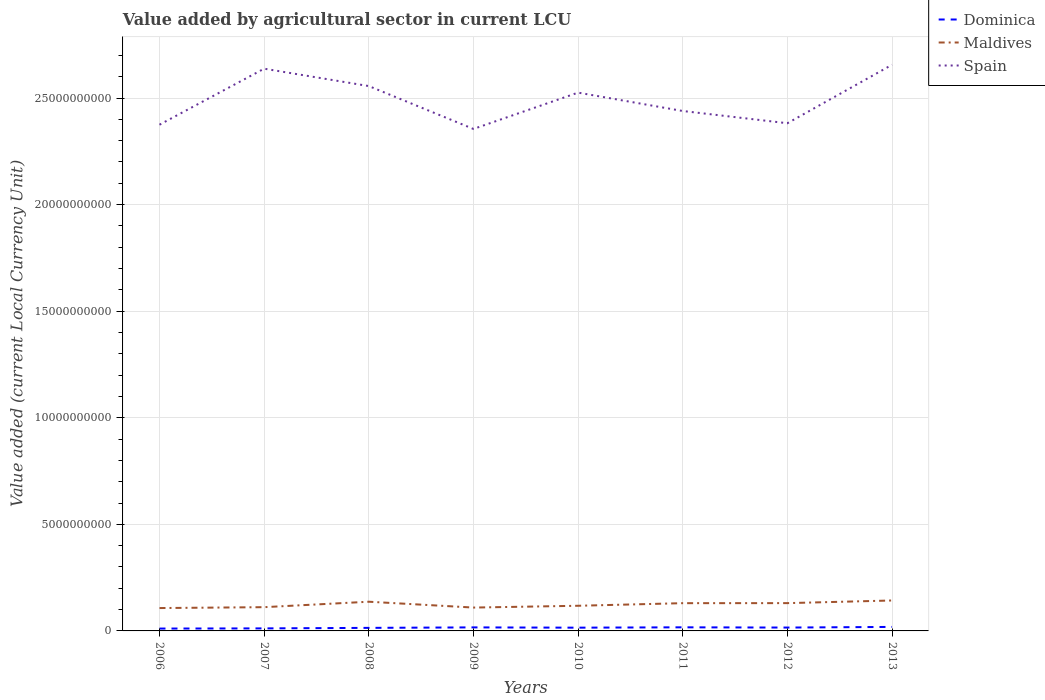Does the line corresponding to Spain intersect with the line corresponding to Maldives?
Your answer should be very brief. No. Is the number of lines equal to the number of legend labels?
Provide a succinct answer. Yes. Across all years, what is the maximum value added by agricultural sector in Dominica?
Make the answer very short. 1.11e+08. In which year was the value added by agricultural sector in Maldives maximum?
Offer a very short reply. 2006. What is the total value added by agricultural sector in Dominica in the graph?
Give a very brief answer. -4.83e+06. What is the difference between the highest and the second highest value added by agricultural sector in Maldives?
Your response must be concise. 3.55e+08. Is the value added by agricultural sector in Maldives strictly greater than the value added by agricultural sector in Spain over the years?
Give a very brief answer. Yes. What is the difference between two consecutive major ticks on the Y-axis?
Offer a very short reply. 5.00e+09. Does the graph contain any zero values?
Give a very brief answer. No. Does the graph contain grids?
Provide a short and direct response. Yes. How are the legend labels stacked?
Offer a very short reply. Vertical. What is the title of the graph?
Ensure brevity in your answer.  Value added by agricultural sector in current LCU. What is the label or title of the X-axis?
Provide a succinct answer. Years. What is the label or title of the Y-axis?
Offer a very short reply. Value added (current Local Currency Unit). What is the Value added (current Local Currency Unit) in Dominica in 2006?
Your answer should be compact. 1.11e+08. What is the Value added (current Local Currency Unit) in Maldives in 2006?
Provide a short and direct response. 1.07e+09. What is the Value added (current Local Currency Unit) in Spain in 2006?
Make the answer very short. 2.37e+1. What is the Value added (current Local Currency Unit) in Dominica in 2007?
Ensure brevity in your answer.  1.19e+08. What is the Value added (current Local Currency Unit) in Maldives in 2007?
Provide a succinct answer. 1.11e+09. What is the Value added (current Local Currency Unit) in Spain in 2007?
Your answer should be compact. 2.64e+1. What is the Value added (current Local Currency Unit) in Dominica in 2008?
Offer a very short reply. 1.43e+08. What is the Value added (current Local Currency Unit) in Maldives in 2008?
Provide a short and direct response. 1.37e+09. What is the Value added (current Local Currency Unit) in Spain in 2008?
Make the answer very short. 2.56e+1. What is the Value added (current Local Currency Unit) of Dominica in 2009?
Your response must be concise. 1.66e+08. What is the Value added (current Local Currency Unit) in Maldives in 2009?
Provide a succinct answer. 1.10e+09. What is the Value added (current Local Currency Unit) in Spain in 2009?
Provide a short and direct response. 2.35e+1. What is the Value added (current Local Currency Unit) of Dominica in 2010?
Give a very brief answer. 1.53e+08. What is the Value added (current Local Currency Unit) in Maldives in 2010?
Offer a terse response. 1.18e+09. What is the Value added (current Local Currency Unit) of Spain in 2010?
Your answer should be very brief. 2.53e+1. What is the Value added (current Local Currency Unit) of Dominica in 2011?
Ensure brevity in your answer.  1.69e+08. What is the Value added (current Local Currency Unit) of Maldives in 2011?
Your response must be concise. 1.30e+09. What is the Value added (current Local Currency Unit) in Spain in 2011?
Give a very brief answer. 2.44e+1. What is the Value added (current Local Currency Unit) of Dominica in 2012?
Provide a succinct answer. 1.58e+08. What is the Value added (current Local Currency Unit) of Maldives in 2012?
Keep it short and to the point. 1.30e+09. What is the Value added (current Local Currency Unit) in Spain in 2012?
Give a very brief answer. 2.38e+1. What is the Value added (current Local Currency Unit) in Dominica in 2013?
Make the answer very short. 1.88e+08. What is the Value added (current Local Currency Unit) in Maldives in 2013?
Provide a succinct answer. 1.43e+09. What is the Value added (current Local Currency Unit) of Spain in 2013?
Provide a succinct answer. 2.66e+1. Across all years, what is the maximum Value added (current Local Currency Unit) of Dominica?
Your answer should be very brief. 1.88e+08. Across all years, what is the maximum Value added (current Local Currency Unit) of Maldives?
Provide a succinct answer. 1.43e+09. Across all years, what is the maximum Value added (current Local Currency Unit) in Spain?
Offer a terse response. 2.66e+1. Across all years, what is the minimum Value added (current Local Currency Unit) in Dominica?
Provide a short and direct response. 1.11e+08. Across all years, what is the minimum Value added (current Local Currency Unit) of Maldives?
Offer a very short reply. 1.07e+09. Across all years, what is the minimum Value added (current Local Currency Unit) in Spain?
Provide a succinct answer. 2.35e+1. What is the total Value added (current Local Currency Unit) in Dominica in the graph?
Provide a succinct answer. 1.21e+09. What is the total Value added (current Local Currency Unit) of Maldives in the graph?
Make the answer very short. 9.87e+09. What is the total Value added (current Local Currency Unit) of Spain in the graph?
Keep it short and to the point. 1.99e+11. What is the difference between the Value added (current Local Currency Unit) of Dominica in 2006 and that in 2007?
Your answer should be very brief. -8.21e+06. What is the difference between the Value added (current Local Currency Unit) of Maldives in 2006 and that in 2007?
Provide a short and direct response. -4.16e+07. What is the difference between the Value added (current Local Currency Unit) in Spain in 2006 and that in 2007?
Ensure brevity in your answer.  -2.63e+09. What is the difference between the Value added (current Local Currency Unit) of Dominica in 2006 and that in 2008?
Make the answer very short. -3.24e+07. What is the difference between the Value added (current Local Currency Unit) of Maldives in 2006 and that in 2008?
Your answer should be very brief. -2.97e+08. What is the difference between the Value added (current Local Currency Unit) in Spain in 2006 and that in 2008?
Provide a short and direct response. -1.81e+09. What is the difference between the Value added (current Local Currency Unit) of Dominica in 2006 and that in 2009?
Keep it short and to the point. -5.51e+07. What is the difference between the Value added (current Local Currency Unit) in Maldives in 2006 and that in 2009?
Ensure brevity in your answer.  -2.32e+07. What is the difference between the Value added (current Local Currency Unit) of Spain in 2006 and that in 2009?
Provide a succinct answer. 1.99e+08. What is the difference between the Value added (current Local Currency Unit) of Dominica in 2006 and that in 2010?
Your answer should be very brief. -4.22e+07. What is the difference between the Value added (current Local Currency Unit) in Maldives in 2006 and that in 2010?
Provide a short and direct response. -1.07e+08. What is the difference between the Value added (current Local Currency Unit) of Spain in 2006 and that in 2010?
Keep it short and to the point. -1.50e+09. What is the difference between the Value added (current Local Currency Unit) in Dominica in 2006 and that in 2011?
Provide a succinct answer. -5.85e+07. What is the difference between the Value added (current Local Currency Unit) in Maldives in 2006 and that in 2011?
Your answer should be very brief. -2.29e+08. What is the difference between the Value added (current Local Currency Unit) in Spain in 2006 and that in 2011?
Provide a short and direct response. -6.43e+08. What is the difference between the Value added (current Local Currency Unit) in Dominica in 2006 and that in 2012?
Offer a very short reply. -4.71e+07. What is the difference between the Value added (current Local Currency Unit) in Maldives in 2006 and that in 2012?
Your response must be concise. -2.31e+08. What is the difference between the Value added (current Local Currency Unit) of Spain in 2006 and that in 2012?
Offer a terse response. -6.90e+07. What is the difference between the Value added (current Local Currency Unit) in Dominica in 2006 and that in 2013?
Offer a terse response. -7.72e+07. What is the difference between the Value added (current Local Currency Unit) of Maldives in 2006 and that in 2013?
Ensure brevity in your answer.  -3.55e+08. What is the difference between the Value added (current Local Currency Unit) of Spain in 2006 and that in 2013?
Your answer should be very brief. -2.81e+09. What is the difference between the Value added (current Local Currency Unit) in Dominica in 2007 and that in 2008?
Offer a terse response. -2.42e+07. What is the difference between the Value added (current Local Currency Unit) of Maldives in 2007 and that in 2008?
Your response must be concise. -2.56e+08. What is the difference between the Value added (current Local Currency Unit) of Spain in 2007 and that in 2008?
Offer a very short reply. 8.15e+08. What is the difference between the Value added (current Local Currency Unit) of Dominica in 2007 and that in 2009?
Your response must be concise. -4.69e+07. What is the difference between the Value added (current Local Currency Unit) of Maldives in 2007 and that in 2009?
Provide a short and direct response. 1.84e+07. What is the difference between the Value added (current Local Currency Unit) in Spain in 2007 and that in 2009?
Provide a short and direct response. 2.83e+09. What is the difference between the Value added (current Local Currency Unit) in Dominica in 2007 and that in 2010?
Your response must be concise. -3.40e+07. What is the difference between the Value added (current Local Currency Unit) in Maldives in 2007 and that in 2010?
Your answer should be compact. -6.58e+07. What is the difference between the Value added (current Local Currency Unit) in Spain in 2007 and that in 2010?
Offer a terse response. 1.12e+09. What is the difference between the Value added (current Local Currency Unit) of Dominica in 2007 and that in 2011?
Your answer should be compact. -5.03e+07. What is the difference between the Value added (current Local Currency Unit) of Maldives in 2007 and that in 2011?
Offer a terse response. -1.88e+08. What is the difference between the Value added (current Local Currency Unit) of Spain in 2007 and that in 2011?
Your answer should be very brief. 1.98e+09. What is the difference between the Value added (current Local Currency Unit) in Dominica in 2007 and that in 2012?
Offer a very short reply. -3.89e+07. What is the difference between the Value added (current Local Currency Unit) of Maldives in 2007 and that in 2012?
Keep it short and to the point. -1.90e+08. What is the difference between the Value added (current Local Currency Unit) in Spain in 2007 and that in 2012?
Provide a succinct answer. 2.56e+09. What is the difference between the Value added (current Local Currency Unit) in Dominica in 2007 and that in 2013?
Your answer should be very brief. -6.90e+07. What is the difference between the Value added (current Local Currency Unit) of Maldives in 2007 and that in 2013?
Your answer should be compact. -3.14e+08. What is the difference between the Value added (current Local Currency Unit) in Spain in 2007 and that in 2013?
Your answer should be very brief. -1.84e+08. What is the difference between the Value added (current Local Currency Unit) in Dominica in 2008 and that in 2009?
Offer a very short reply. -2.27e+07. What is the difference between the Value added (current Local Currency Unit) in Maldives in 2008 and that in 2009?
Give a very brief answer. 2.74e+08. What is the difference between the Value added (current Local Currency Unit) in Spain in 2008 and that in 2009?
Your answer should be very brief. 2.01e+09. What is the difference between the Value added (current Local Currency Unit) of Dominica in 2008 and that in 2010?
Offer a very short reply. -9.81e+06. What is the difference between the Value added (current Local Currency Unit) of Maldives in 2008 and that in 2010?
Make the answer very short. 1.90e+08. What is the difference between the Value added (current Local Currency Unit) of Spain in 2008 and that in 2010?
Your answer should be very brief. 3.08e+08. What is the difference between the Value added (current Local Currency Unit) in Dominica in 2008 and that in 2011?
Give a very brief answer. -2.60e+07. What is the difference between the Value added (current Local Currency Unit) of Maldives in 2008 and that in 2011?
Your response must be concise. 6.81e+07. What is the difference between the Value added (current Local Currency Unit) in Spain in 2008 and that in 2011?
Give a very brief answer. 1.17e+09. What is the difference between the Value added (current Local Currency Unit) of Dominica in 2008 and that in 2012?
Give a very brief answer. -1.46e+07. What is the difference between the Value added (current Local Currency Unit) in Maldives in 2008 and that in 2012?
Your answer should be very brief. 6.62e+07. What is the difference between the Value added (current Local Currency Unit) of Spain in 2008 and that in 2012?
Ensure brevity in your answer.  1.74e+09. What is the difference between the Value added (current Local Currency Unit) in Dominica in 2008 and that in 2013?
Offer a terse response. -4.47e+07. What is the difference between the Value added (current Local Currency Unit) of Maldives in 2008 and that in 2013?
Give a very brief answer. -5.80e+07. What is the difference between the Value added (current Local Currency Unit) of Spain in 2008 and that in 2013?
Give a very brief answer. -9.99e+08. What is the difference between the Value added (current Local Currency Unit) of Dominica in 2009 and that in 2010?
Your answer should be very brief. 1.29e+07. What is the difference between the Value added (current Local Currency Unit) of Maldives in 2009 and that in 2010?
Your response must be concise. -8.42e+07. What is the difference between the Value added (current Local Currency Unit) of Spain in 2009 and that in 2010?
Provide a short and direct response. -1.70e+09. What is the difference between the Value added (current Local Currency Unit) of Dominica in 2009 and that in 2011?
Keep it short and to the point. -3.37e+06. What is the difference between the Value added (current Local Currency Unit) of Maldives in 2009 and that in 2011?
Ensure brevity in your answer.  -2.06e+08. What is the difference between the Value added (current Local Currency Unit) of Spain in 2009 and that in 2011?
Make the answer very short. -8.42e+08. What is the difference between the Value added (current Local Currency Unit) in Dominica in 2009 and that in 2012?
Keep it short and to the point. 8.03e+06. What is the difference between the Value added (current Local Currency Unit) in Maldives in 2009 and that in 2012?
Keep it short and to the point. -2.08e+08. What is the difference between the Value added (current Local Currency Unit) of Spain in 2009 and that in 2012?
Provide a short and direct response. -2.68e+08. What is the difference between the Value added (current Local Currency Unit) in Dominica in 2009 and that in 2013?
Provide a succinct answer. -2.21e+07. What is the difference between the Value added (current Local Currency Unit) of Maldives in 2009 and that in 2013?
Your answer should be very brief. -3.32e+08. What is the difference between the Value added (current Local Currency Unit) in Spain in 2009 and that in 2013?
Offer a terse response. -3.01e+09. What is the difference between the Value added (current Local Currency Unit) of Dominica in 2010 and that in 2011?
Offer a terse response. -1.62e+07. What is the difference between the Value added (current Local Currency Unit) of Maldives in 2010 and that in 2011?
Make the answer very short. -1.22e+08. What is the difference between the Value added (current Local Currency Unit) in Spain in 2010 and that in 2011?
Make the answer very short. 8.62e+08. What is the difference between the Value added (current Local Currency Unit) of Dominica in 2010 and that in 2012?
Your answer should be very brief. -4.83e+06. What is the difference between the Value added (current Local Currency Unit) in Maldives in 2010 and that in 2012?
Provide a succinct answer. -1.24e+08. What is the difference between the Value added (current Local Currency Unit) in Spain in 2010 and that in 2012?
Your answer should be very brief. 1.44e+09. What is the difference between the Value added (current Local Currency Unit) of Dominica in 2010 and that in 2013?
Offer a terse response. -3.49e+07. What is the difference between the Value added (current Local Currency Unit) in Maldives in 2010 and that in 2013?
Offer a terse response. -2.48e+08. What is the difference between the Value added (current Local Currency Unit) in Spain in 2010 and that in 2013?
Offer a very short reply. -1.31e+09. What is the difference between the Value added (current Local Currency Unit) of Dominica in 2011 and that in 2012?
Give a very brief answer. 1.14e+07. What is the difference between the Value added (current Local Currency Unit) in Maldives in 2011 and that in 2012?
Give a very brief answer. -1.90e+06. What is the difference between the Value added (current Local Currency Unit) of Spain in 2011 and that in 2012?
Your response must be concise. 5.74e+08. What is the difference between the Value added (current Local Currency Unit) of Dominica in 2011 and that in 2013?
Give a very brief answer. -1.87e+07. What is the difference between the Value added (current Local Currency Unit) of Maldives in 2011 and that in 2013?
Your response must be concise. -1.26e+08. What is the difference between the Value added (current Local Currency Unit) in Spain in 2011 and that in 2013?
Your answer should be very brief. -2.17e+09. What is the difference between the Value added (current Local Currency Unit) of Dominica in 2012 and that in 2013?
Make the answer very short. -3.01e+07. What is the difference between the Value added (current Local Currency Unit) of Maldives in 2012 and that in 2013?
Keep it short and to the point. -1.24e+08. What is the difference between the Value added (current Local Currency Unit) in Spain in 2012 and that in 2013?
Your response must be concise. -2.74e+09. What is the difference between the Value added (current Local Currency Unit) in Dominica in 2006 and the Value added (current Local Currency Unit) in Maldives in 2007?
Offer a terse response. -1.00e+09. What is the difference between the Value added (current Local Currency Unit) of Dominica in 2006 and the Value added (current Local Currency Unit) of Spain in 2007?
Your response must be concise. -2.63e+1. What is the difference between the Value added (current Local Currency Unit) of Maldives in 2006 and the Value added (current Local Currency Unit) of Spain in 2007?
Your response must be concise. -2.53e+1. What is the difference between the Value added (current Local Currency Unit) in Dominica in 2006 and the Value added (current Local Currency Unit) in Maldives in 2008?
Keep it short and to the point. -1.26e+09. What is the difference between the Value added (current Local Currency Unit) in Dominica in 2006 and the Value added (current Local Currency Unit) in Spain in 2008?
Keep it short and to the point. -2.55e+1. What is the difference between the Value added (current Local Currency Unit) in Maldives in 2006 and the Value added (current Local Currency Unit) in Spain in 2008?
Make the answer very short. -2.45e+1. What is the difference between the Value added (current Local Currency Unit) in Dominica in 2006 and the Value added (current Local Currency Unit) in Maldives in 2009?
Offer a very short reply. -9.85e+08. What is the difference between the Value added (current Local Currency Unit) in Dominica in 2006 and the Value added (current Local Currency Unit) in Spain in 2009?
Make the answer very short. -2.34e+1. What is the difference between the Value added (current Local Currency Unit) in Maldives in 2006 and the Value added (current Local Currency Unit) in Spain in 2009?
Your answer should be very brief. -2.25e+1. What is the difference between the Value added (current Local Currency Unit) in Dominica in 2006 and the Value added (current Local Currency Unit) in Maldives in 2010?
Offer a terse response. -1.07e+09. What is the difference between the Value added (current Local Currency Unit) in Dominica in 2006 and the Value added (current Local Currency Unit) in Spain in 2010?
Make the answer very short. -2.51e+1. What is the difference between the Value added (current Local Currency Unit) of Maldives in 2006 and the Value added (current Local Currency Unit) of Spain in 2010?
Offer a very short reply. -2.42e+1. What is the difference between the Value added (current Local Currency Unit) of Dominica in 2006 and the Value added (current Local Currency Unit) of Maldives in 2011?
Offer a very short reply. -1.19e+09. What is the difference between the Value added (current Local Currency Unit) of Dominica in 2006 and the Value added (current Local Currency Unit) of Spain in 2011?
Make the answer very short. -2.43e+1. What is the difference between the Value added (current Local Currency Unit) of Maldives in 2006 and the Value added (current Local Currency Unit) of Spain in 2011?
Offer a terse response. -2.33e+1. What is the difference between the Value added (current Local Currency Unit) of Dominica in 2006 and the Value added (current Local Currency Unit) of Maldives in 2012?
Give a very brief answer. -1.19e+09. What is the difference between the Value added (current Local Currency Unit) of Dominica in 2006 and the Value added (current Local Currency Unit) of Spain in 2012?
Offer a very short reply. -2.37e+1. What is the difference between the Value added (current Local Currency Unit) in Maldives in 2006 and the Value added (current Local Currency Unit) in Spain in 2012?
Provide a short and direct response. -2.27e+1. What is the difference between the Value added (current Local Currency Unit) of Dominica in 2006 and the Value added (current Local Currency Unit) of Maldives in 2013?
Provide a short and direct response. -1.32e+09. What is the difference between the Value added (current Local Currency Unit) in Dominica in 2006 and the Value added (current Local Currency Unit) in Spain in 2013?
Your answer should be compact. -2.64e+1. What is the difference between the Value added (current Local Currency Unit) of Maldives in 2006 and the Value added (current Local Currency Unit) of Spain in 2013?
Your response must be concise. -2.55e+1. What is the difference between the Value added (current Local Currency Unit) of Dominica in 2007 and the Value added (current Local Currency Unit) of Maldives in 2008?
Your answer should be very brief. -1.25e+09. What is the difference between the Value added (current Local Currency Unit) of Dominica in 2007 and the Value added (current Local Currency Unit) of Spain in 2008?
Ensure brevity in your answer.  -2.54e+1. What is the difference between the Value added (current Local Currency Unit) of Maldives in 2007 and the Value added (current Local Currency Unit) of Spain in 2008?
Provide a succinct answer. -2.44e+1. What is the difference between the Value added (current Local Currency Unit) in Dominica in 2007 and the Value added (current Local Currency Unit) in Maldives in 2009?
Ensure brevity in your answer.  -9.77e+08. What is the difference between the Value added (current Local Currency Unit) in Dominica in 2007 and the Value added (current Local Currency Unit) in Spain in 2009?
Offer a terse response. -2.34e+1. What is the difference between the Value added (current Local Currency Unit) in Maldives in 2007 and the Value added (current Local Currency Unit) in Spain in 2009?
Provide a short and direct response. -2.24e+1. What is the difference between the Value added (current Local Currency Unit) of Dominica in 2007 and the Value added (current Local Currency Unit) of Maldives in 2010?
Offer a terse response. -1.06e+09. What is the difference between the Value added (current Local Currency Unit) in Dominica in 2007 and the Value added (current Local Currency Unit) in Spain in 2010?
Offer a terse response. -2.51e+1. What is the difference between the Value added (current Local Currency Unit) in Maldives in 2007 and the Value added (current Local Currency Unit) in Spain in 2010?
Your answer should be very brief. -2.41e+1. What is the difference between the Value added (current Local Currency Unit) of Dominica in 2007 and the Value added (current Local Currency Unit) of Maldives in 2011?
Offer a very short reply. -1.18e+09. What is the difference between the Value added (current Local Currency Unit) of Dominica in 2007 and the Value added (current Local Currency Unit) of Spain in 2011?
Make the answer very short. -2.43e+1. What is the difference between the Value added (current Local Currency Unit) of Maldives in 2007 and the Value added (current Local Currency Unit) of Spain in 2011?
Provide a succinct answer. -2.33e+1. What is the difference between the Value added (current Local Currency Unit) of Dominica in 2007 and the Value added (current Local Currency Unit) of Maldives in 2012?
Give a very brief answer. -1.18e+09. What is the difference between the Value added (current Local Currency Unit) in Dominica in 2007 and the Value added (current Local Currency Unit) in Spain in 2012?
Your answer should be compact. -2.37e+1. What is the difference between the Value added (current Local Currency Unit) in Maldives in 2007 and the Value added (current Local Currency Unit) in Spain in 2012?
Offer a terse response. -2.27e+1. What is the difference between the Value added (current Local Currency Unit) in Dominica in 2007 and the Value added (current Local Currency Unit) in Maldives in 2013?
Ensure brevity in your answer.  -1.31e+09. What is the difference between the Value added (current Local Currency Unit) in Dominica in 2007 and the Value added (current Local Currency Unit) in Spain in 2013?
Your answer should be compact. -2.64e+1. What is the difference between the Value added (current Local Currency Unit) of Maldives in 2007 and the Value added (current Local Currency Unit) of Spain in 2013?
Provide a succinct answer. -2.54e+1. What is the difference between the Value added (current Local Currency Unit) of Dominica in 2008 and the Value added (current Local Currency Unit) of Maldives in 2009?
Give a very brief answer. -9.53e+08. What is the difference between the Value added (current Local Currency Unit) of Dominica in 2008 and the Value added (current Local Currency Unit) of Spain in 2009?
Provide a short and direct response. -2.34e+1. What is the difference between the Value added (current Local Currency Unit) in Maldives in 2008 and the Value added (current Local Currency Unit) in Spain in 2009?
Provide a short and direct response. -2.22e+1. What is the difference between the Value added (current Local Currency Unit) in Dominica in 2008 and the Value added (current Local Currency Unit) in Maldives in 2010?
Your answer should be very brief. -1.04e+09. What is the difference between the Value added (current Local Currency Unit) in Dominica in 2008 and the Value added (current Local Currency Unit) in Spain in 2010?
Ensure brevity in your answer.  -2.51e+1. What is the difference between the Value added (current Local Currency Unit) of Maldives in 2008 and the Value added (current Local Currency Unit) of Spain in 2010?
Your response must be concise. -2.39e+1. What is the difference between the Value added (current Local Currency Unit) in Dominica in 2008 and the Value added (current Local Currency Unit) in Maldives in 2011?
Your answer should be very brief. -1.16e+09. What is the difference between the Value added (current Local Currency Unit) of Dominica in 2008 and the Value added (current Local Currency Unit) of Spain in 2011?
Your response must be concise. -2.42e+1. What is the difference between the Value added (current Local Currency Unit) in Maldives in 2008 and the Value added (current Local Currency Unit) in Spain in 2011?
Ensure brevity in your answer.  -2.30e+1. What is the difference between the Value added (current Local Currency Unit) of Dominica in 2008 and the Value added (current Local Currency Unit) of Maldives in 2012?
Provide a short and direct response. -1.16e+09. What is the difference between the Value added (current Local Currency Unit) in Dominica in 2008 and the Value added (current Local Currency Unit) in Spain in 2012?
Offer a terse response. -2.37e+1. What is the difference between the Value added (current Local Currency Unit) of Maldives in 2008 and the Value added (current Local Currency Unit) of Spain in 2012?
Provide a succinct answer. -2.24e+1. What is the difference between the Value added (current Local Currency Unit) in Dominica in 2008 and the Value added (current Local Currency Unit) in Maldives in 2013?
Offer a very short reply. -1.28e+09. What is the difference between the Value added (current Local Currency Unit) of Dominica in 2008 and the Value added (current Local Currency Unit) of Spain in 2013?
Keep it short and to the point. -2.64e+1. What is the difference between the Value added (current Local Currency Unit) in Maldives in 2008 and the Value added (current Local Currency Unit) in Spain in 2013?
Your response must be concise. -2.52e+1. What is the difference between the Value added (current Local Currency Unit) in Dominica in 2009 and the Value added (current Local Currency Unit) in Maldives in 2010?
Your response must be concise. -1.01e+09. What is the difference between the Value added (current Local Currency Unit) of Dominica in 2009 and the Value added (current Local Currency Unit) of Spain in 2010?
Keep it short and to the point. -2.51e+1. What is the difference between the Value added (current Local Currency Unit) of Maldives in 2009 and the Value added (current Local Currency Unit) of Spain in 2010?
Provide a succinct answer. -2.42e+1. What is the difference between the Value added (current Local Currency Unit) in Dominica in 2009 and the Value added (current Local Currency Unit) in Maldives in 2011?
Provide a short and direct response. -1.14e+09. What is the difference between the Value added (current Local Currency Unit) in Dominica in 2009 and the Value added (current Local Currency Unit) in Spain in 2011?
Ensure brevity in your answer.  -2.42e+1. What is the difference between the Value added (current Local Currency Unit) in Maldives in 2009 and the Value added (current Local Currency Unit) in Spain in 2011?
Your response must be concise. -2.33e+1. What is the difference between the Value added (current Local Currency Unit) of Dominica in 2009 and the Value added (current Local Currency Unit) of Maldives in 2012?
Provide a short and direct response. -1.14e+09. What is the difference between the Value added (current Local Currency Unit) of Dominica in 2009 and the Value added (current Local Currency Unit) of Spain in 2012?
Keep it short and to the point. -2.37e+1. What is the difference between the Value added (current Local Currency Unit) in Maldives in 2009 and the Value added (current Local Currency Unit) in Spain in 2012?
Your answer should be very brief. -2.27e+1. What is the difference between the Value added (current Local Currency Unit) of Dominica in 2009 and the Value added (current Local Currency Unit) of Maldives in 2013?
Provide a succinct answer. -1.26e+09. What is the difference between the Value added (current Local Currency Unit) in Dominica in 2009 and the Value added (current Local Currency Unit) in Spain in 2013?
Provide a succinct answer. -2.64e+1. What is the difference between the Value added (current Local Currency Unit) in Maldives in 2009 and the Value added (current Local Currency Unit) in Spain in 2013?
Make the answer very short. -2.55e+1. What is the difference between the Value added (current Local Currency Unit) in Dominica in 2010 and the Value added (current Local Currency Unit) in Maldives in 2011?
Offer a terse response. -1.15e+09. What is the difference between the Value added (current Local Currency Unit) in Dominica in 2010 and the Value added (current Local Currency Unit) in Spain in 2011?
Offer a very short reply. -2.42e+1. What is the difference between the Value added (current Local Currency Unit) of Maldives in 2010 and the Value added (current Local Currency Unit) of Spain in 2011?
Your answer should be compact. -2.32e+1. What is the difference between the Value added (current Local Currency Unit) in Dominica in 2010 and the Value added (current Local Currency Unit) in Maldives in 2012?
Your response must be concise. -1.15e+09. What is the difference between the Value added (current Local Currency Unit) in Dominica in 2010 and the Value added (current Local Currency Unit) in Spain in 2012?
Ensure brevity in your answer.  -2.37e+1. What is the difference between the Value added (current Local Currency Unit) of Maldives in 2010 and the Value added (current Local Currency Unit) of Spain in 2012?
Make the answer very short. -2.26e+1. What is the difference between the Value added (current Local Currency Unit) of Dominica in 2010 and the Value added (current Local Currency Unit) of Maldives in 2013?
Your response must be concise. -1.28e+09. What is the difference between the Value added (current Local Currency Unit) of Dominica in 2010 and the Value added (current Local Currency Unit) of Spain in 2013?
Make the answer very short. -2.64e+1. What is the difference between the Value added (current Local Currency Unit) of Maldives in 2010 and the Value added (current Local Currency Unit) of Spain in 2013?
Provide a succinct answer. -2.54e+1. What is the difference between the Value added (current Local Currency Unit) in Dominica in 2011 and the Value added (current Local Currency Unit) in Maldives in 2012?
Provide a short and direct response. -1.13e+09. What is the difference between the Value added (current Local Currency Unit) in Dominica in 2011 and the Value added (current Local Currency Unit) in Spain in 2012?
Offer a very short reply. -2.36e+1. What is the difference between the Value added (current Local Currency Unit) of Maldives in 2011 and the Value added (current Local Currency Unit) of Spain in 2012?
Provide a succinct answer. -2.25e+1. What is the difference between the Value added (current Local Currency Unit) in Dominica in 2011 and the Value added (current Local Currency Unit) in Maldives in 2013?
Offer a terse response. -1.26e+09. What is the difference between the Value added (current Local Currency Unit) of Dominica in 2011 and the Value added (current Local Currency Unit) of Spain in 2013?
Keep it short and to the point. -2.64e+1. What is the difference between the Value added (current Local Currency Unit) of Maldives in 2011 and the Value added (current Local Currency Unit) of Spain in 2013?
Offer a terse response. -2.53e+1. What is the difference between the Value added (current Local Currency Unit) in Dominica in 2012 and the Value added (current Local Currency Unit) in Maldives in 2013?
Your answer should be compact. -1.27e+09. What is the difference between the Value added (current Local Currency Unit) of Dominica in 2012 and the Value added (current Local Currency Unit) of Spain in 2013?
Provide a succinct answer. -2.64e+1. What is the difference between the Value added (current Local Currency Unit) of Maldives in 2012 and the Value added (current Local Currency Unit) of Spain in 2013?
Offer a terse response. -2.53e+1. What is the average Value added (current Local Currency Unit) in Dominica per year?
Give a very brief answer. 1.51e+08. What is the average Value added (current Local Currency Unit) in Maldives per year?
Your answer should be compact. 1.23e+09. What is the average Value added (current Local Currency Unit) in Spain per year?
Provide a short and direct response. 2.49e+1. In the year 2006, what is the difference between the Value added (current Local Currency Unit) in Dominica and Value added (current Local Currency Unit) in Maldives?
Ensure brevity in your answer.  -9.62e+08. In the year 2006, what is the difference between the Value added (current Local Currency Unit) in Dominica and Value added (current Local Currency Unit) in Spain?
Offer a terse response. -2.36e+1. In the year 2006, what is the difference between the Value added (current Local Currency Unit) of Maldives and Value added (current Local Currency Unit) of Spain?
Offer a very short reply. -2.27e+1. In the year 2007, what is the difference between the Value added (current Local Currency Unit) in Dominica and Value added (current Local Currency Unit) in Maldives?
Offer a terse response. -9.95e+08. In the year 2007, what is the difference between the Value added (current Local Currency Unit) of Dominica and Value added (current Local Currency Unit) of Spain?
Offer a terse response. -2.63e+1. In the year 2007, what is the difference between the Value added (current Local Currency Unit) in Maldives and Value added (current Local Currency Unit) in Spain?
Keep it short and to the point. -2.53e+1. In the year 2008, what is the difference between the Value added (current Local Currency Unit) of Dominica and Value added (current Local Currency Unit) of Maldives?
Your answer should be very brief. -1.23e+09. In the year 2008, what is the difference between the Value added (current Local Currency Unit) in Dominica and Value added (current Local Currency Unit) in Spain?
Make the answer very short. -2.54e+1. In the year 2008, what is the difference between the Value added (current Local Currency Unit) in Maldives and Value added (current Local Currency Unit) in Spain?
Ensure brevity in your answer.  -2.42e+1. In the year 2009, what is the difference between the Value added (current Local Currency Unit) of Dominica and Value added (current Local Currency Unit) of Maldives?
Ensure brevity in your answer.  -9.30e+08. In the year 2009, what is the difference between the Value added (current Local Currency Unit) in Dominica and Value added (current Local Currency Unit) in Spain?
Offer a terse response. -2.34e+1. In the year 2009, what is the difference between the Value added (current Local Currency Unit) of Maldives and Value added (current Local Currency Unit) of Spain?
Provide a short and direct response. -2.25e+1. In the year 2010, what is the difference between the Value added (current Local Currency Unit) in Dominica and Value added (current Local Currency Unit) in Maldives?
Your answer should be compact. -1.03e+09. In the year 2010, what is the difference between the Value added (current Local Currency Unit) in Dominica and Value added (current Local Currency Unit) in Spain?
Your answer should be compact. -2.51e+1. In the year 2010, what is the difference between the Value added (current Local Currency Unit) in Maldives and Value added (current Local Currency Unit) in Spain?
Ensure brevity in your answer.  -2.41e+1. In the year 2011, what is the difference between the Value added (current Local Currency Unit) of Dominica and Value added (current Local Currency Unit) of Maldives?
Offer a very short reply. -1.13e+09. In the year 2011, what is the difference between the Value added (current Local Currency Unit) in Dominica and Value added (current Local Currency Unit) in Spain?
Make the answer very short. -2.42e+1. In the year 2011, what is the difference between the Value added (current Local Currency Unit) of Maldives and Value added (current Local Currency Unit) of Spain?
Offer a very short reply. -2.31e+1. In the year 2012, what is the difference between the Value added (current Local Currency Unit) of Dominica and Value added (current Local Currency Unit) of Maldives?
Provide a succinct answer. -1.15e+09. In the year 2012, what is the difference between the Value added (current Local Currency Unit) in Dominica and Value added (current Local Currency Unit) in Spain?
Offer a terse response. -2.37e+1. In the year 2012, what is the difference between the Value added (current Local Currency Unit) of Maldives and Value added (current Local Currency Unit) of Spain?
Keep it short and to the point. -2.25e+1. In the year 2013, what is the difference between the Value added (current Local Currency Unit) of Dominica and Value added (current Local Currency Unit) of Maldives?
Your answer should be very brief. -1.24e+09. In the year 2013, what is the difference between the Value added (current Local Currency Unit) in Dominica and Value added (current Local Currency Unit) in Spain?
Make the answer very short. -2.64e+1. In the year 2013, what is the difference between the Value added (current Local Currency Unit) in Maldives and Value added (current Local Currency Unit) in Spain?
Your response must be concise. -2.51e+1. What is the ratio of the Value added (current Local Currency Unit) in Dominica in 2006 to that in 2007?
Give a very brief answer. 0.93. What is the ratio of the Value added (current Local Currency Unit) in Maldives in 2006 to that in 2007?
Keep it short and to the point. 0.96. What is the ratio of the Value added (current Local Currency Unit) in Spain in 2006 to that in 2007?
Provide a succinct answer. 0.9. What is the ratio of the Value added (current Local Currency Unit) of Dominica in 2006 to that in 2008?
Your answer should be compact. 0.77. What is the ratio of the Value added (current Local Currency Unit) of Maldives in 2006 to that in 2008?
Provide a short and direct response. 0.78. What is the ratio of the Value added (current Local Currency Unit) in Spain in 2006 to that in 2008?
Keep it short and to the point. 0.93. What is the ratio of the Value added (current Local Currency Unit) of Dominica in 2006 to that in 2009?
Ensure brevity in your answer.  0.67. What is the ratio of the Value added (current Local Currency Unit) of Maldives in 2006 to that in 2009?
Your answer should be compact. 0.98. What is the ratio of the Value added (current Local Currency Unit) in Spain in 2006 to that in 2009?
Offer a terse response. 1.01. What is the ratio of the Value added (current Local Currency Unit) in Dominica in 2006 to that in 2010?
Your response must be concise. 0.72. What is the ratio of the Value added (current Local Currency Unit) of Maldives in 2006 to that in 2010?
Provide a short and direct response. 0.91. What is the ratio of the Value added (current Local Currency Unit) in Spain in 2006 to that in 2010?
Your response must be concise. 0.94. What is the ratio of the Value added (current Local Currency Unit) in Dominica in 2006 to that in 2011?
Make the answer very short. 0.65. What is the ratio of the Value added (current Local Currency Unit) in Maldives in 2006 to that in 2011?
Your answer should be very brief. 0.82. What is the ratio of the Value added (current Local Currency Unit) in Spain in 2006 to that in 2011?
Keep it short and to the point. 0.97. What is the ratio of the Value added (current Local Currency Unit) in Dominica in 2006 to that in 2012?
Offer a very short reply. 0.7. What is the ratio of the Value added (current Local Currency Unit) in Maldives in 2006 to that in 2012?
Provide a short and direct response. 0.82. What is the ratio of the Value added (current Local Currency Unit) in Spain in 2006 to that in 2012?
Offer a very short reply. 1. What is the ratio of the Value added (current Local Currency Unit) in Dominica in 2006 to that in 2013?
Offer a very short reply. 0.59. What is the ratio of the Value added (current Local Currency Unit) of Maldives in 2006 to that in 2013?
Provide a short and direct response. 0.75. What is the ratio of the Value added (current Local Currency Unit) in Spain in 2006 to that in 2013?
Offer a very short reply. 0.89. What is the ratio of the Value added (current Local Currency Unit) of Dominica in 2007 to that in 2008?
Your answer should be very brief. 0.83. What is the ratio of the Value added (current Local Currency Unit) in Maldives in 2007 to that in 2008?
Your response must be concise. 0.81. What is the ratio of the Value added (current Local Currency Unit) of Spain in 2007 to that in 2008?
Keep it short and to the point. 1.03. What is the ratio of the Value added (current Local Currency Unit) of Dominica in 2007 to that in 2009?
Your answer should be very brief. 0.72. What is the ratio of the Value added (current Local Currency Unit) of Maldives in 2007 to that in 2009?
Make the answer very short. 1.02. What is the ratio of the Value added (current Local Currency Unit) in Spain in 2007 to that in 2009?
Make the answer very short. 1.12. What is the ratio of the Value added (current Local Currency Unit) of Dominica in 2007 to that in 2010?
Offer a very short reply. 0.78. What is the ratio of the Value added (current Local Currency Unit) of Maldives in 2007 to that in 2010?
Offer a very short reply. 0.94. What is the ratio of the Value added (current Local Currency Unit) in Spain in 2007 to that in 2010?
Your answer should be very brief. 1.04. What is the ratio of the Value added (current Local Currency Unit) in Dominica in 2007 to that in 2011?
Your answer should be compact. 0.7. What is the ratio of the Value added (current Local Currency Unit) in Maldives in 2007 to that in 2011?
Offer a terse response. 0.86. What is the ratio of the Value added (current Local Currency Unit) in Spain in 2007 to that in 2011?
Offer a very short reply. 1.08. What is the ratio of the Value added (current Local Currency Unit) of Dominica in 2007 to that in 2012?
Ensure brevity in your answer.  0.75. What is the ratio of the Value added (current Local Currency Unit) of Maldives in 2007 to that in 2012?
Your answer should be very brief. 0.85. What is the ratio of the Value added (current Local Currency Unit) in Spain in 2007 to that in 2012?
Ensure brevity in your answer.  1.11. What is the ratio of the Value added (current Local Currency Unit) of Dominica in 2007 to that in 2013?
Provide a succinct answer. 0.63. What is the ratio of the Value added (current Local Currency Unit) in Maldives in 2007 to that in 2013?
Your answer should be very brief. 0.78. What is the ratio of the Value added (current Local Currency Unit) in Spain in 2007 to that in 2013?
Offer a very short reply. 0.99. What is the ratio of the Value added (current Local Currency Unit) in Dominica in 2008 to that in 2009?
Your response must be concise. 0.86. What is the ratio of the Value added (current Local Currency Unit) in Maldives in 2008 to that in 2009?
Provide a short and direct response. 1.25. What is the ratio of the Value added (current Local Currency Unit) of Spain in 2008 to that in 2009?
Provide a succinct answer. 1.09. What is the ratio of the Value added (current Local Currency Unit) of Dominica in 2008 to that in 2010?
Provide a short and direct response. 0.94. What is the ratio of the Value added (current Local Currency Unit) in Maldives in 2008 to that in 2010?
Offer a very short reply. 1.16. What is the ratio of the Value added (current Local Currency Unit) in Spain in 2008 to that in 2010?
Make the answer very short. 1.01. What is the ratio of the Value added (current Local Currency Unit) in Dominica in 2008 to that in 2011?
Ensure brevity in your answer.  0.85. What is the ratio of the Value added (current Local Currency Unit) in Maldives in 2008 to that in 2011?
Offer a very short reply. 1.05. What is the ratio of the Value added (current Local Currency Unit) in Spain in 2008 to that in 2011?
Give a very brief answer. 1.05. What is the ratio of the Value added (current Local Currency Unit) in Dominica in 2008 to that in 2012?
Offer a terse response. 0.91. What is the ratio of the Value added (current Local Currency Unit) of Maldives in 2008 to that in 2012?
Your answer should be compact. 1.05. What is the ratio of the Value added (current Local Currency Unit) of Spain in 2008 to that in 2012?
Provide a short and direct response. 1.07. What is the ratio of the Value added (current Local Currency Unit) of Dominica in 2008 to that in 2013?
Your answer should be very brief. 0.76. What is the ratio of the Value added (current Local Currency Unit) of Maldives in 2008 to that in 2013?
Provide a succinct answer. 0.96. What is the ratio of the Value added (current Local Currency Unit) in Spain in 2008 to that in 2013?
Provide a short and direct response. 0.96. What is the ratio of the Value added (current Local Currency Unit) in Dominica in 2009 to that in 2010?
Provide a short and direct response. 1.08. What is the ratio of the Value added (current Local Currency Unit) of Spain in 2009 to that in 2010?
Ensure brevity in your answer.  0.93. What is the ratio of the Value added (current Local Currency Unit) of Dominica in 2009 to that in 2011?
Ensure brevity in your answer.  0.98. What is the ratio of the Value added (current Local Currency Unit) of Maldives in 2009 to that in 2011?
Offer a very short reply. 0.84. What is the ratio of the Value added (current Local Currency Unit) of Spain in 2009 to that in 2011?
Your answer should be compact. 0.97. What is the ratio of the Value added (current Local Currency Unit) in Dominica in 2009 to that in 2012?
Provide a short and direct response. 1.05. What is the ratio of the Value added (current Local Currency Unit) of Maldives in 2009 to that in 2012?
Offer a terse response. 0.84. What is the ratio of the Value added (current Local Currency Unit) of Spain in 2009 to that in 2012?
Your response must be concise. 0.99. What is the ratio of the Value added (current Local Currency Unit) in Dominica in 2009 to that in 2013?
Provide a short and direct response. 0.88. What is the ratio of the Value added (current Local Currency Unit) of Maldives in 2009 to that in 2013?
Your answer should be compact. 0.77. What is the ratio of the Value added (current Local Currency Unit) of Spain in 2009 to that in 2013?
Your answer should be very brief. 0.89. What is the ratio of the Value added (current Local Currency Unit) of Dominica in 2010 to that in 2011?
Give a very brief answer. 0.9. What is the ratio of the Value added (current Local Currency Unit) of Maldives in 2010 to that in 2011?
Your answer should be compact. 0.91. What is the ratio of the Value added (current Local Currency Unit) of Spain in 2010 to that in 2011?
Your response must be concise. 1.04. What is the ratio of the Value added (current Local Currency Unit) of Dominica in 2010 to that in 2012?
Make the answer very short. 0.97. What is the ratio of the Value added (current Local Currency Unit) in Maldives in 2010 to that in 2012?
Make the answer very short. 0.91. What is the ratio of the Value added (current Local Currency Unit) of Spain in 2010 to that in 2012?
Provide a short and direct response. 1.06. What is the ratio of the Value added (current Local Currency Unit) of Dominica in 2010 to that in 2013?
Give a very brief answer. 0.81. What is the ratio of the Value added (current Local Currency Unit) of Maldives in 2010 to that in 2013?
Provide a short and direct response. 0.83. What is the ratio of the Value added (current Local Currency Unit) of Spain in 2010 to that in 2013?
Give a very brief answer. 0.95. What is the ratio of the Value added (current Local Currency Unit) of Dominica in 2011 to that in 2012?
Keep it short and to the point. 1.07. What is the ratio of the Value added (current Local Currency Unit) in Spain in 2011 to that in 2012?
Your answer should be very brief. 1.02. What is the ratio of the Value added (current Local Currency Unit) of Dominica in 2011 to that in 2013?
Offer a terse response. 0.9. What is the ratio of the Value added (current Local Currency Unit) of Maldives in 2011 to that in 2013?
Keep it short and to the point. 0.91. What is the ratio of the Value added (current Local Currency Unit) of Spain in 2011 to that in 2013?
Your answer should be compact. 0.92. What is the ratio of the Value added (current Local Currency Unit) in Dominica in 2012 to that in 2013?
Keep it short and to the point. 0.84. What is the ratio of the Value added (current Local Currency Unit) in Maldives in 2012 to that in 2013?
Your answer should be compact. 0.91. What is the ratio of the Value added (current Local Currency Unit) in Spain in 2012 to that in 2013?
Offer a very short reply. 0.9. What is the difference between the highest and the second highest Value added (current Local Currency Unit) in Dominica?
Your answer should be compact. 1.87e+07. What is the difference between the highest and the second highest Value added (current Local Currency Unit) of Maldives?
Keep it short and to the point. 5.80e+07. What is the difference between the highest and the second highest Value added (current Local Currency Unit) of Spain?
Ensure brevity in your answer.  1.84e+08. What is the difference between the highest and the lowest Value added (current Local Currency Unit) of Dominica?
Make the answer very short. 7.72e+07. What is the difference between the highest and the lowest Value added (current Local Currency Unit) of Maldives?
Offer a very short reply. 3.55e+08. What is the difference between the highest and the lowest Value added (current Local Currency Unit) in Spain?
Your answer should be very brief. 3.01e+09. 